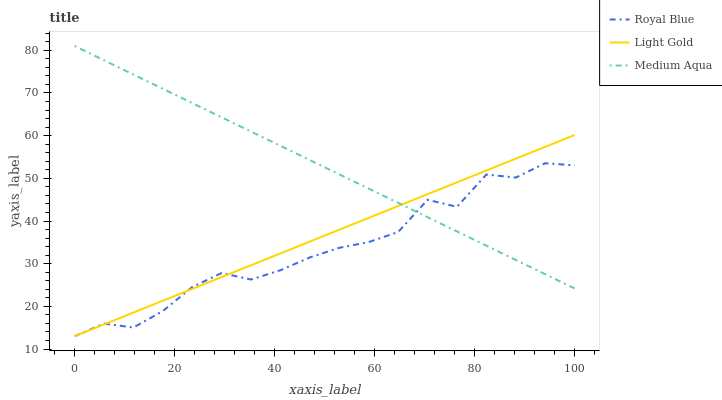Does Royal Blue have the minimum area under the curve?
Answer yes or no. Yes. Does Medium Aqua have the maximum area under the curve?
Answer yes or no. Yes. Does Light Gold have the minimum area under the curve?
Answer yes or no. No. Does Light Gold have the maximum area under the curve?
Answer yes or no. No. Is Light Gold the smoothest?
Answer yes or no. Yes. Is Royal Blue the roughest?
Answer yes or no. Yes. Is Royal Blue the smoothest?
Answer yes or no. No. Is Light Gold the roughest?
Answer yes or no. No. Does Royal Blue have the lowest value?
Answer yes or no. Yes. Does Medium Aqua have the highest value?
Answer yes or no. Yes. Does Light Gold have the highest value?
Answer yes or no. No. Does Royal Blue intersect Light Gold?
Answer yes or no. Yes. Is Royal Blue less than Light Gold?
Answer yes or no. No. Is Royal Blue greater than Light Gold?
Answer yes or no. No. 